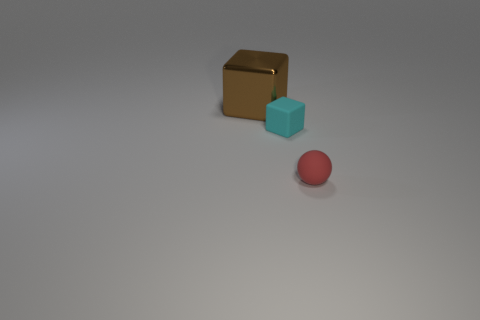Is there any other thing that is the same size as the brown thing?
Your answer should be compact. No. What color is the other big thing that is the same shape as the cyan thing?
Your answer should be compact. Brown. What number of small red spheres are to the left of the tiny thing that is to the right of the tiny thing behind the red object?
Offer a terse response. 0. Is there any other thing that is made of the same material as the large brown cube?
Your answer should be very brief. No. Are there fewer metal things left of the big brown metal thing than big cyan rubber things?
Provide a short and direct response. No. Do the tiny rubber cube and the big cube have the same color?
Offer a very short reply. No. There is a matte object that is the same shape as the large shiny object; what is its size?
Your response must be concise. Small. How many other cyan cubes are the same material as the tiny cyan block?
Give a very brief answer. 0. Is the material of the tiny thing to the left of the red rubber object the same as the tiny red ball?
Offer a terse response. Yes. Is the number of matte balls that are on the left side of the metal cube the same as the number of green rubber objects?
Your answer should be compact. Yes. 